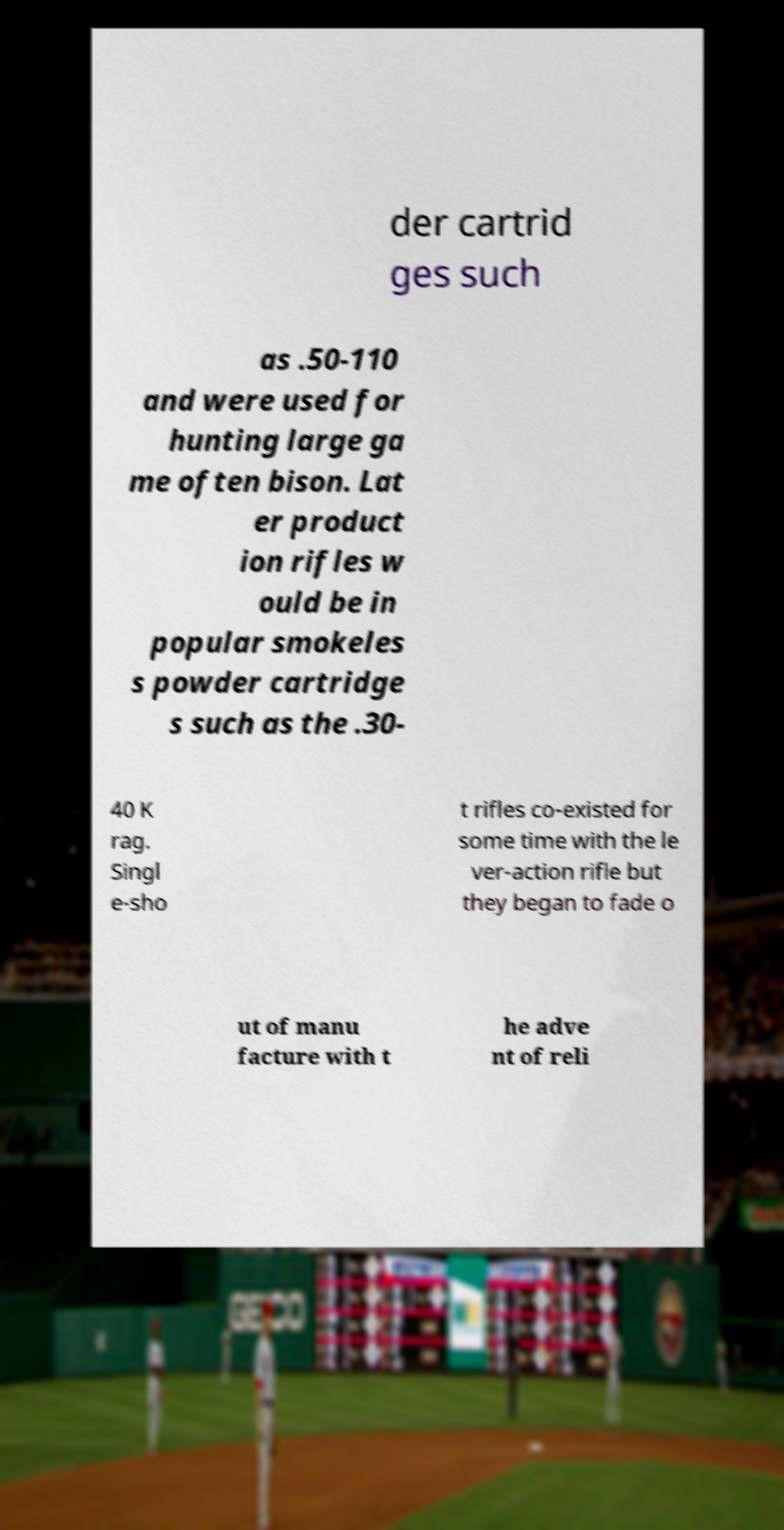Can you read and provide the text displayed in the image?This photo seems to have some interesting text. Can you extract and type it out for me? der cartrid ges such as .50-110 and were used for hunting large ga me often bison. Lat er product ion rifles w ould be in popular smokeles s powder cartridge s such as the .30- 40 K rag. Singl e-sho t rifles co-existed for some time with the le ver-action rifle but they began to fade o ut of manu facture with t he adve nt of reli 